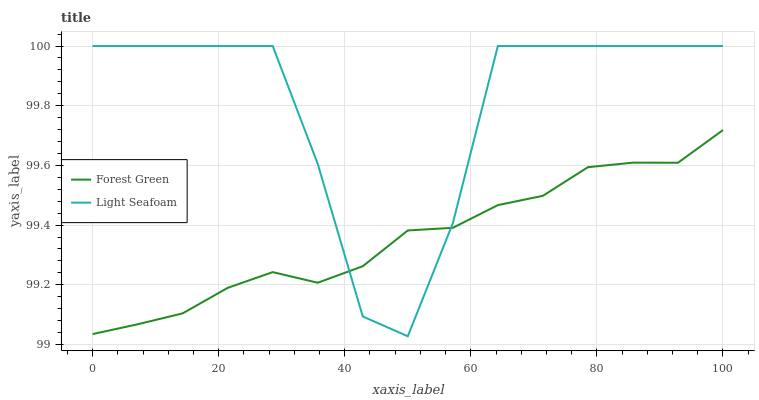Does Forest Green have the minimum area under the curve?
Answer yes or no. Yes. Does Light Seafoam have the maximum area under the curve?
Answer yes or no. Yes. Does Light Seafoam have the minimum area under the curve?
Answer yes or no. No. Is Forest Green the smoothest?
Answer yes or no. Yes. Is Light Seafoam the roughest?
Answer yes or no. Yes. Is Light Seafoam the smoothest?
Answer yes or no. No. Does Light Seafoam have the lowest value?
Answer yes or no. Yes. Does Light Seafoam have the highest value?
Answer yes or no. Yes. Does Light Seafoam intersect Forest Green?
Answer yes or no. Yes. Is Light Seafoam less than Forest Green?
Answer yes or no. No. Is Light Seafoam greater than Forest Green?
Answer yes or no. No. 